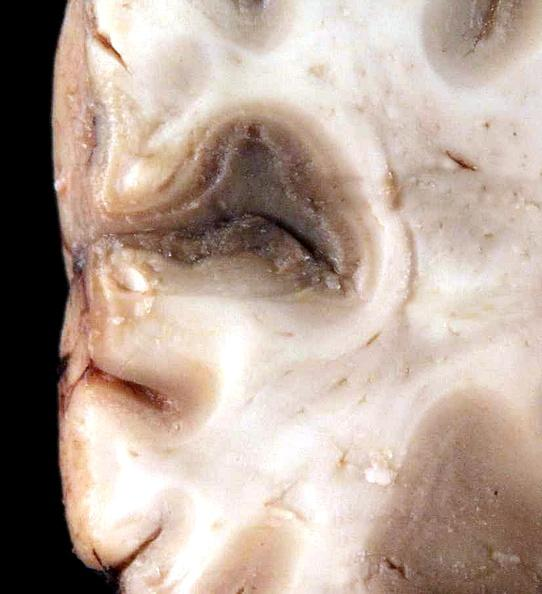s nervous present?
Answer the question using a single word or phrase. Yes 